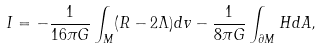Convert formula to latex. <formula><loc_0><loc_0><loc_500><loc_500>I = - \frac { 1 } { 1 6 \pi G } \int _ { M } ( R - 2 \Lambda ) d v - \frac { 1 } { 8 \pi G } \int _ { \partial M } H d A ,</formula> 